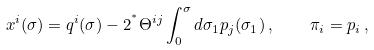<formula> <loc_0><loc_0><loc_500><loc_500>x ^ { i } ( \sigma ) = q ^ { i } ( \sigma ) - 2 ^ { ^ { * } } \Theta ^ { i j } \int _ { 0 } ^ { \sigma } d \sigma _ { 1 } p _ { j } ( \sigma _ { 1 } ) \, , \quad \pi _ { i } = p _ { i } \, ,</formula> 